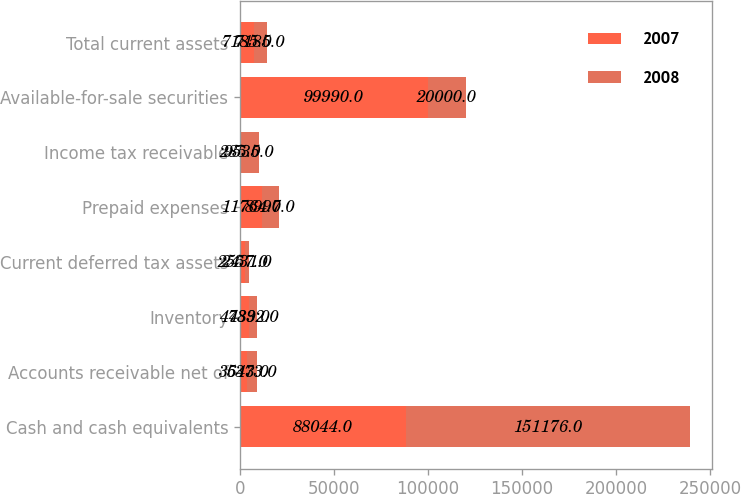<chart> <loc_0><loc_0><loc_500><loc_500><stacked_bar_chart><ecel><fcel>Cash and cash equivalents<fcel>Accounts receivable net of<fcel>Inventory<fcel>Current deferred tax assets<fcel>Prepaid expenses<fcel>Income tax receivable<fcel>Available-for-sale securities<fcel>Total current assets<nl><fcel>2007<fcel>88044<fcel>3643<fcel>4789<fcel>2557<fcel>11764<fcel>285<fcel>99990<fcel>7185<nl><fcel>2008<fcel>151176<fcel>5373<fcel>4332<fcel>2431<fcel>8997<fcel>9535<fcel>20000<fcel>7185<nl></chart> 